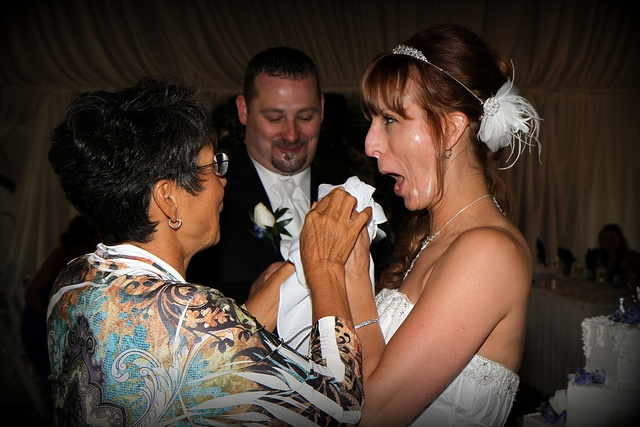Describe the objects in this image and their specific colors. I can see people in black, gray, brown, and darkgray tones, people in black, salmon, and maroon tones, people in black, maroon, lightgray, and darkgray tones, cake in black and gray tones, and people in black tones in this image. 